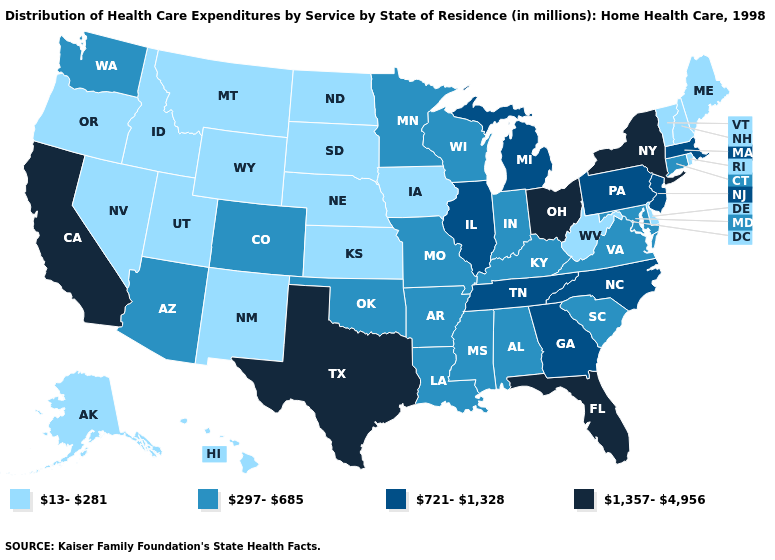Name the states that have a value in the range 1,357-4,956?
Answer briefly. California, Florida, New York, Ohio, Texas. Does Utah have the lowest value in the West?
Concise answer only. Yes. Name the states that have a value in the range 13-281?
Concise answer only. Alaska, Delaware, Hawaii, Idaho, Iowa, Kansas, Maine, Montana, Nebraska, Nevada, New Hampshire, New Mexico, North Dakota, Oregon, Rhode Island, South Dakota, Utah, Vermont, West Virginia, Wyoming. Name the states that have a value in the range 13-281?
Give a very brief answer. Alaska, Delaware, Hawaii, Idaho, Iowa, Kansas, Maine, Montana, Nebraska, Nevada, New Hampshire, New Mexico, North Dakota, Oregon, Rhode Island, South Dakota, Utah, Vermont, West Virginia, Wyoming. Which states have the highest value in the USA?
Give a very brief answer. California, Florida, New York, Ohio, Texas. Does New Mexico have the lowest value in the USA?
Quick response, please. Yes. What is the value of South Carolina?
Keep it brief. 297-685. Name the states that have a value in the range 297-685?
Concise answer only. Alabama, Arizona, Arkansas, Colorado, Connecticut, Indiana, Kentucky, Louisiana, Maryland, Minnesota, Mississippi, Missouri, Oklahoma, South Carolina, Virginia, Washington, Wisconsin. What is the value of Nebraska?
Give a very brief answer. 13-281. What is the lowest value in the USA?
Be succinct. 13-281. Does Utah have the lowest value in the West?
Be succinct. Yes. Name the states that have a value in the range 1,357-4,956?
Concise answer only. California, Florida, New York, Ohio, Texas. What is the value of Washington?
Write a very short answer. 297-685. Name the states that have a value in the range 13-281?
Keep it brief. Alaska, Delaware, Hawaii, Idaho, Iowa, Kansas, Maine, Montana, Nebraska, Nevada, New Hampshire, New Mexico, North Dakota, Oregon, Rhode Island, South Dakota, Utah, Vermont, West Virginia, Wyoming. How many symbols are there in the legend?
Give a very brief answer. 4. 